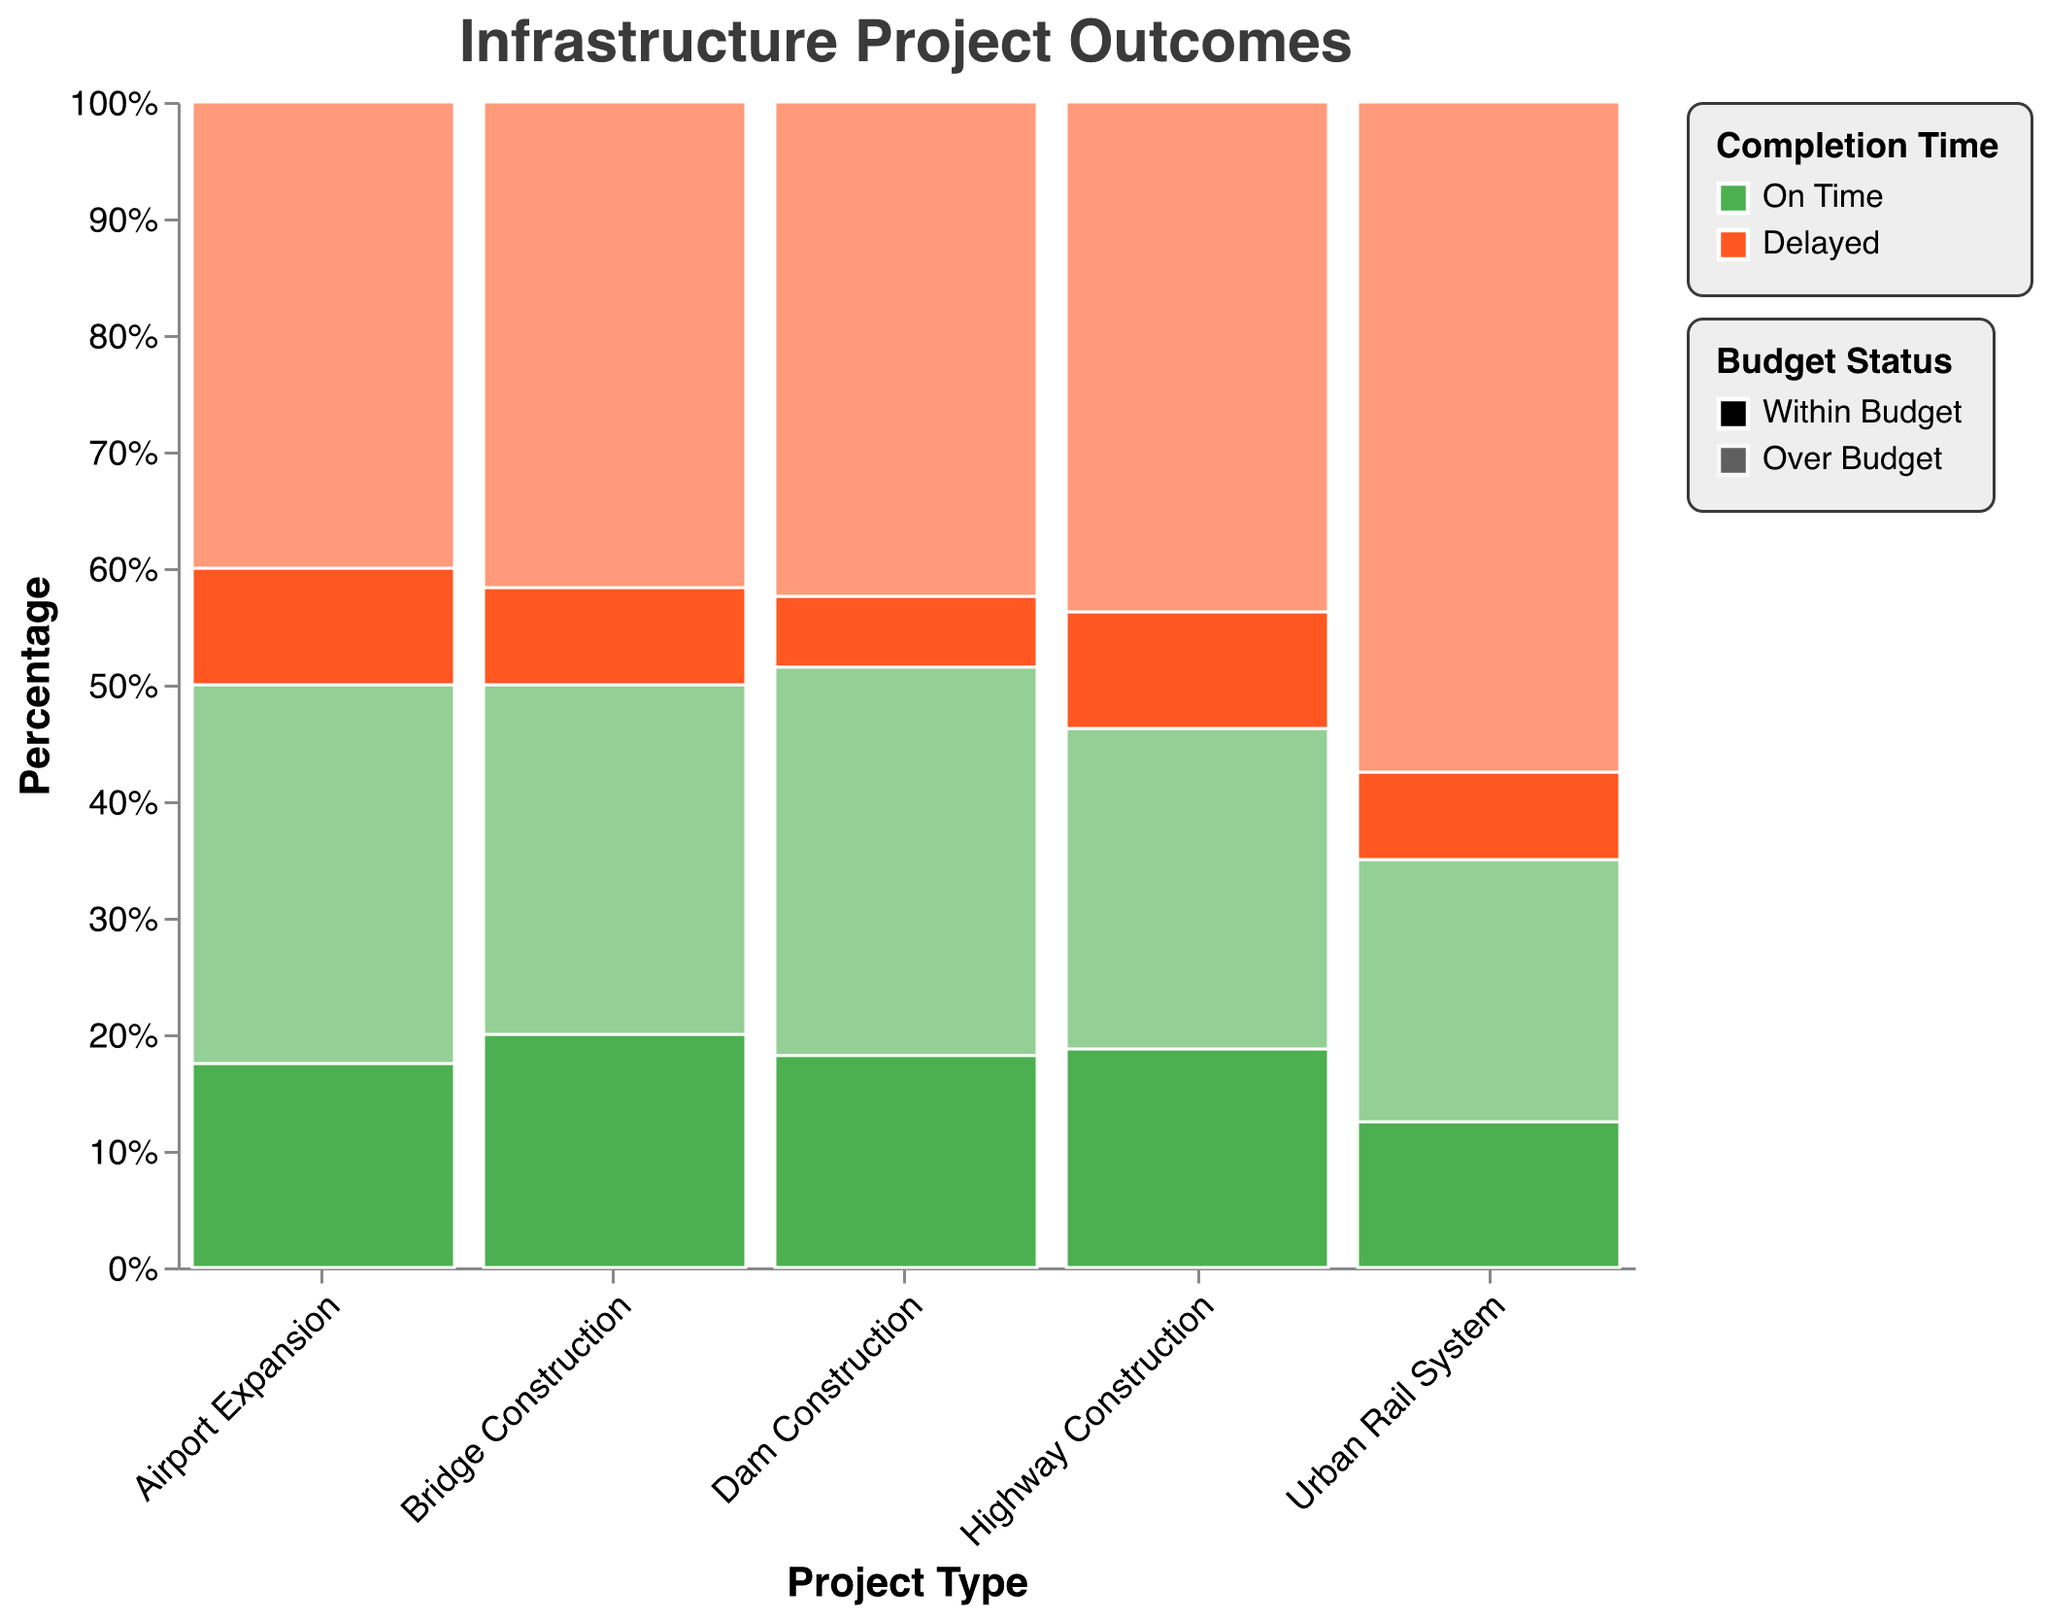What is the title of the figure? The title of the figure is placed at the top and provides an overview of what the plot represents.
Answer: Infrastructure Project Outcomes Which project type has the highest percentage of delayed and over-budget results? Look for the segment in the plot that represents delayed and over-budget results for each project type and compare their relative sizes.
Answer: Highway Construction What percentage of Bridge Construction projects were delayed and within budget? Identify the segment for Bridge Construction projects that were both delayed and within budget and check its percentage along the y-axis.
Answer: Approximately 5% How does the percentage of on-time and within-budget completions compare between Highway Construction and Urban Rail Systems? Compare the height of the bars for on-time and within-budget segments between Highway Construction and Urban Rail Systems.
Answer: Highway Construction has a higher percentage For which type of project is budget overrun most common when projects are delayed? Examine each project type's delayed segments with different opacities representing budget overrun and check which has the highest percentage.
Answer: Highway Construction What is the ratio of delayed to on-time projects in Dam Construction? Sum the segments for all delayed projects and divide by the sum of all on-time projects for Dam Construction.
Answer: 2:1 In which project type is the frequency of projects completed within budget higher when delayed? Look at the segments for each project type that represents delayed and within-budget projects, then compare their percentages.
Answer: Airport Expansion Which project type has the smallest proportion of on-time and over-budget completions? Identify the segment for each project type that represents on-time and over-budget completions and compare their proportions.
Answer: Urban Rail System 